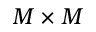Convert formula to latex. <formula><loc_0><loc_0><loc_500><loc_500>M \times M</formula> 